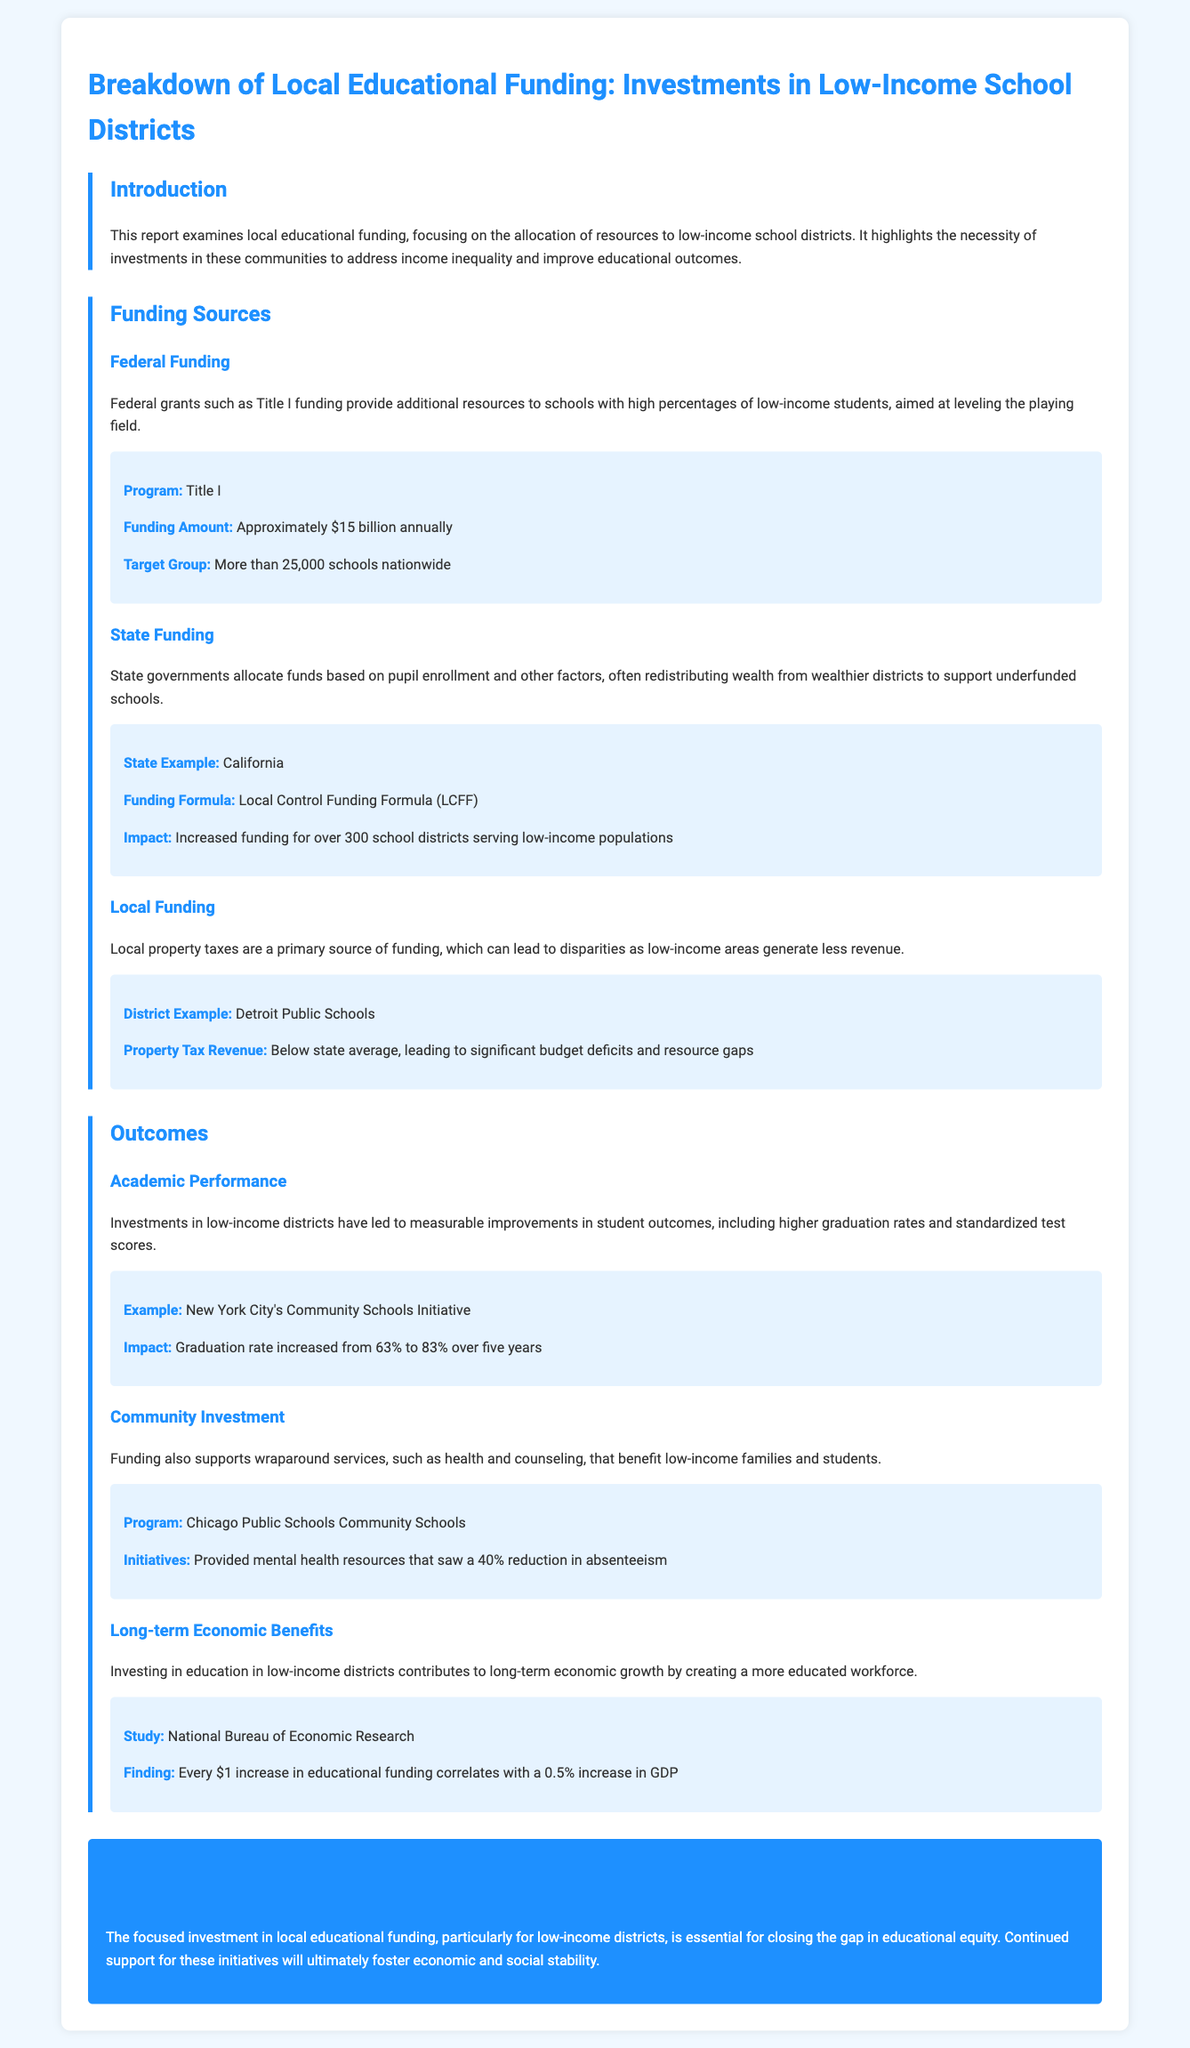What is the federal funding amount for Title I? The document states that Title I funding provides approximately $15 billion annually.
Answer: $15 billion What is the impact of California's Local Control Funding Formula? The document notes that it increased funding for over 300 school districts serving low-income populations.
Answer: Increased funding for over 300 school districts What percentage did New York City's graduation rate increase to over five years? The report illustrates that the graduation rate increased from 63% to 83% over five years.
Answer: 83% What is the primary source of local funding for schools? The document indicates that local property taxes are the primary source of funding, which can lead to disparities.
Answer: Local property taxes What was the reduction in absenteeism achieved by Chicago Public Schools Community Schools? According to the document, there was a 40% reduction in absenteeism after providing mental health resources.
Answer: 40% What is the correlation between educational funding and GDP according to the study mentioned? The document mentions that every $1 increase in educational funding correlates with a 0.5% increase in GDP.
Answer: 0.5% increase in GDP What was the target group for Title I funding? The document specifies that Title I funding targets more than 25,000 schools nationwide.
Answer: More than 25,000 schools What was the graduation rate before the New York City Community Schools Initiative? The document states that the graduation rate increased from 63%, implying it was 63% before the initiative.
Answer: 63% What service does community investment in education support? The report highlights that funding supports wraparound services, such as health and counseling.
Answer: Health and counseling services 